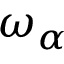Convert formula to latex. <formula><loc_0><loc_0><loc_500><loc_500>\omega _ { \alpha }</formula> 